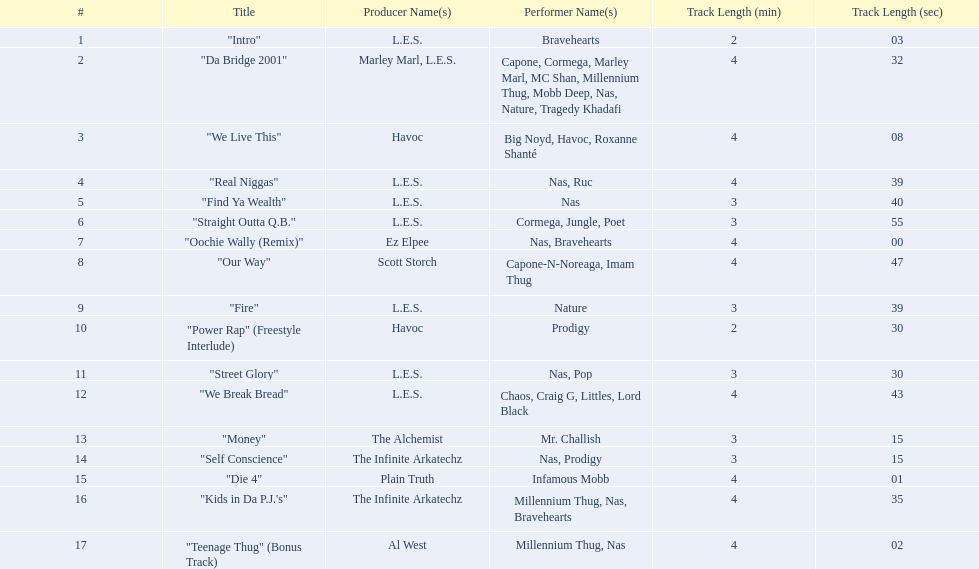Which is longer, fire or die 4? "Die 4". 